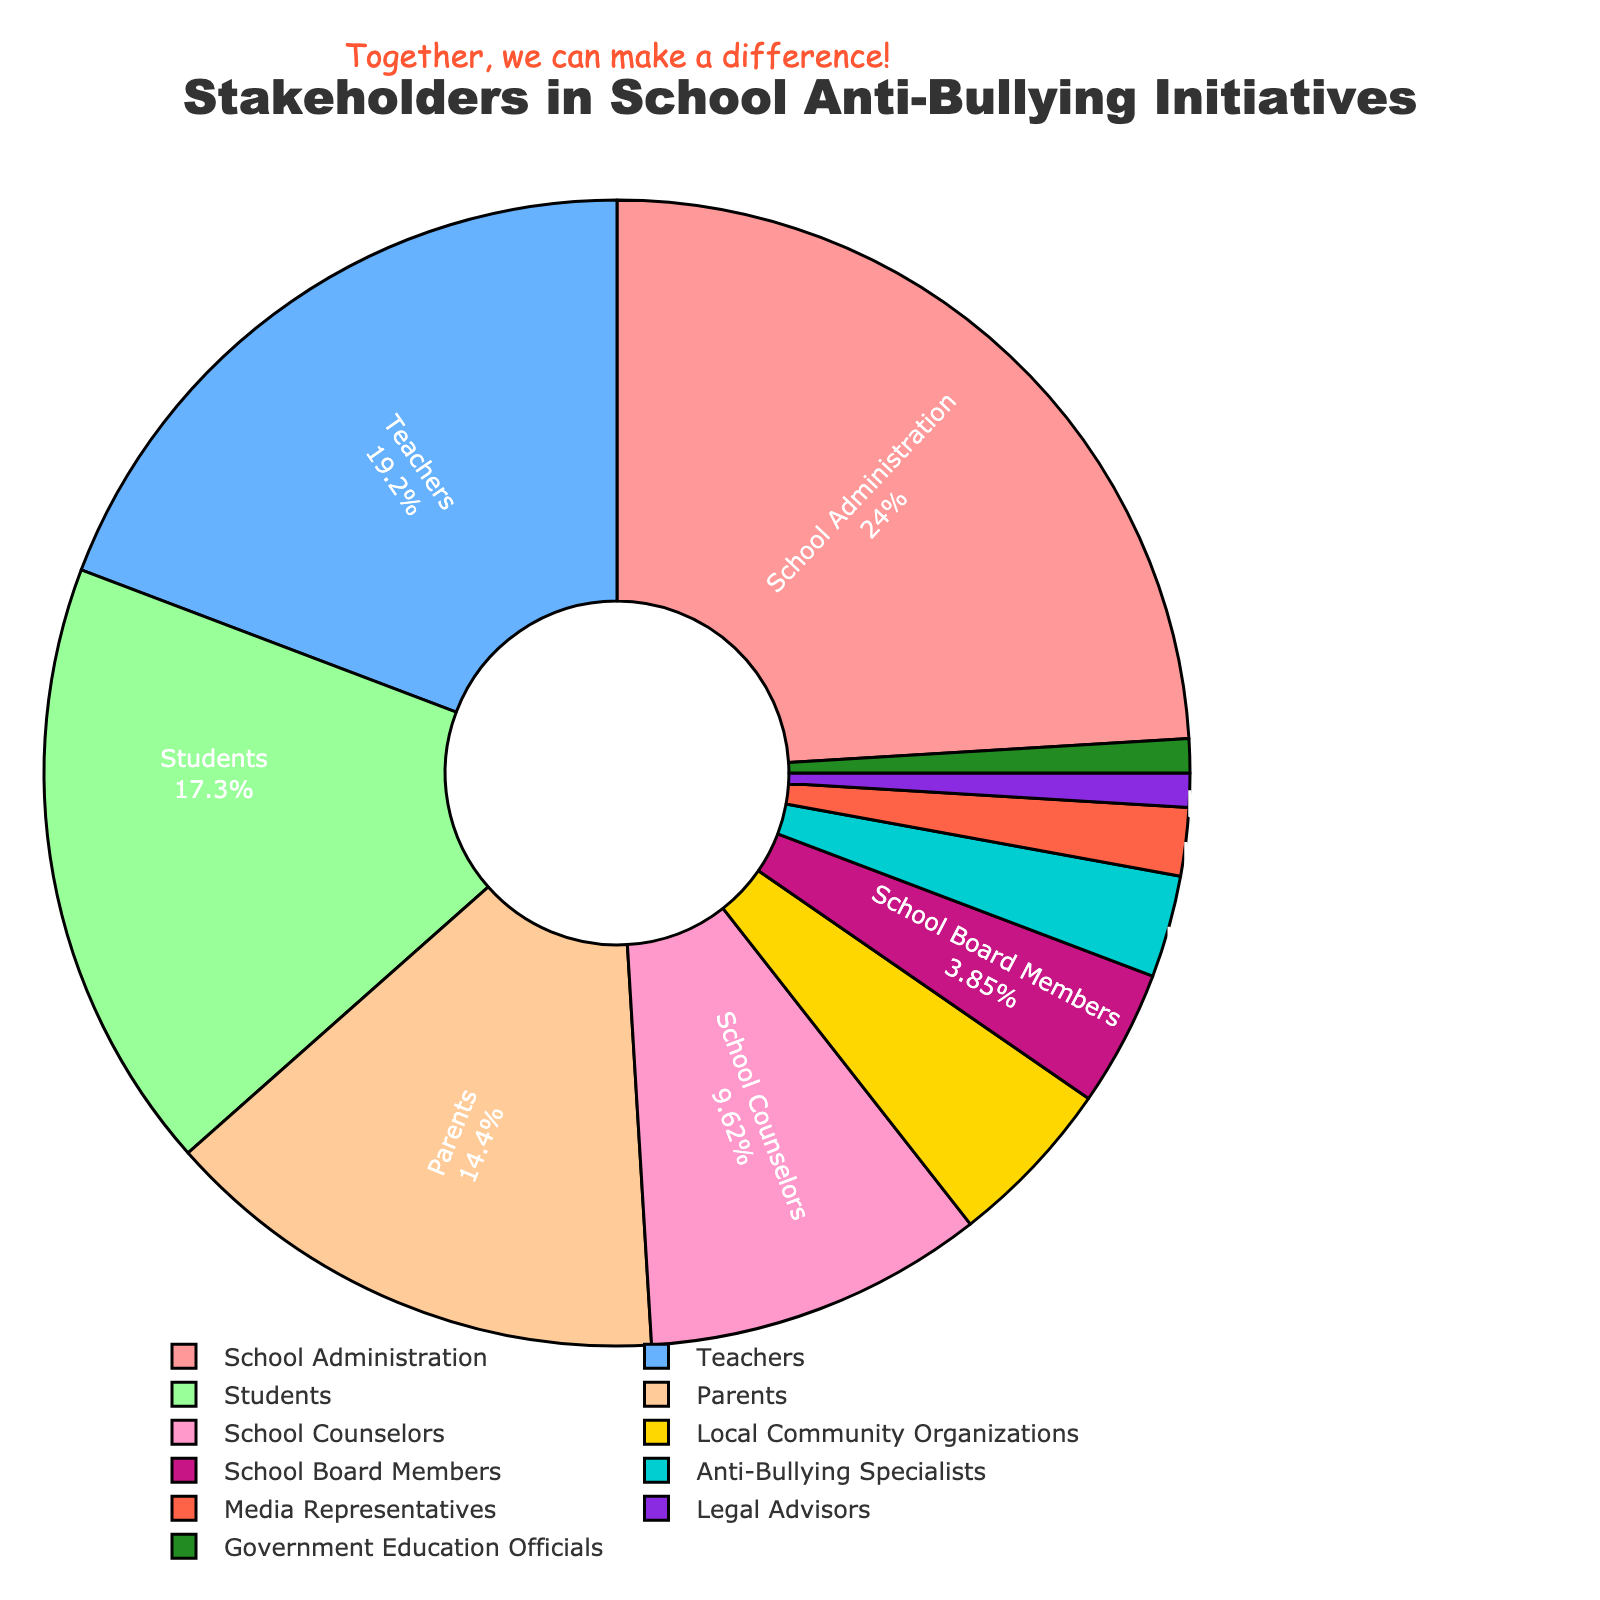Which stakeholder group contributes the most to school anti-bullying initiatives? The figure shows the percentage breakdown of stakeholders involved. School Administration has the highest percentage of 25%.
Answer: School Administration How much higher is the percentage of Teachers compared to Parents? The percentage of Teachers is 20% and Parents is 15%. The difference is 20% - 15% = 5%.
Answer: 5% Which stakeholders combined have a total contribution equal to the contribution of School Administration? School Administration is 25%. The combined percentages of Local Community Organizations (5%), School Board Members (4%), Anti-Bullying Specialists (3%), Media Representatives (2%), Legal Advisors (1%), and Government Education Officials (1%) is 5% + 4% + 3% + 2% + 1% + 1% = 16%. Including School Counselors (10%) along with the previous stakeholders totals 16% + 10% = 26%, which is slightly higher than 25%. Thus, School Counselors alone are about equivalent with 10%.
Answer: School Counselors, Local Community Organizations, School Board Members, Anti-Bullying Specialists, Media Representatives, Legal Advisors, Government Education Officials What portion of the pie chart is taken up by Students and Parents together? Adding the percentages of Students (18%) and Parents (15%) gives 18% + 15% = 33%.
Answer: 33% How does the contribution of Teachers compare to that of School Counselors and Anti-Bullying Specialists combined? Teachers contribute 20%. School Counselors contribute 10% and Anti-Bullying Specialists contribute 3%, so combined they contribute 10% + 3% = 13%. Therefore, Teachers' contribution is higher than that of School Counselors and Anti-Bullying Specialists combined.
Answer: Teachers' contribution is higher What percentage of stakeholders contribute less than 5% each to anti-bullying initiatives? Adding percentages of stakeholders contributing less than 5%: School Board Members (4%), Anti-Bullying Specialists (3%), Media Representatives (2%), Legal Advisors (1%), Government Education Officials (1%), giving a total of 4% + 3% + 2% + 1% + 1% = 11%.
Answer: 11% What are the colors representing the highest and lowest contributions? The highest contribution of 25% by School Administration is represented by a red-ish color, and the lowest contribution of 1% by Legal Advisors and Government Education Officials is represented by green and another distinct color respectively.
Answer: Red and Green/Distinct By how much does the percentage of School Counselors exceed that of Local Community Organizations? School Counselors have 10%, and Local Community Organizations have 5%. The difference is 10% - 5% = 5%.
Answer: 5% If Media Representatives’ and Legal Advisors’ contributions were doubled, what would their combined percentage be? Media Representatives contribute 2%, and Legal Advisors contribute 1%. Doubling their percentages gives (2% * 2) + (1% * 2) = 4% + 2% = 6%.
Answer: 6% What stakeholders combined contribute to more than half of the total effort? Adding from the highest contribution to lower until we surpass 50%: School Administration (25%) + Teachers (20%) = 45%. Including Students (18%) makes it 45% + 18% = 63%, which is more than half.
Answer: School Administration, Teachers, Students 